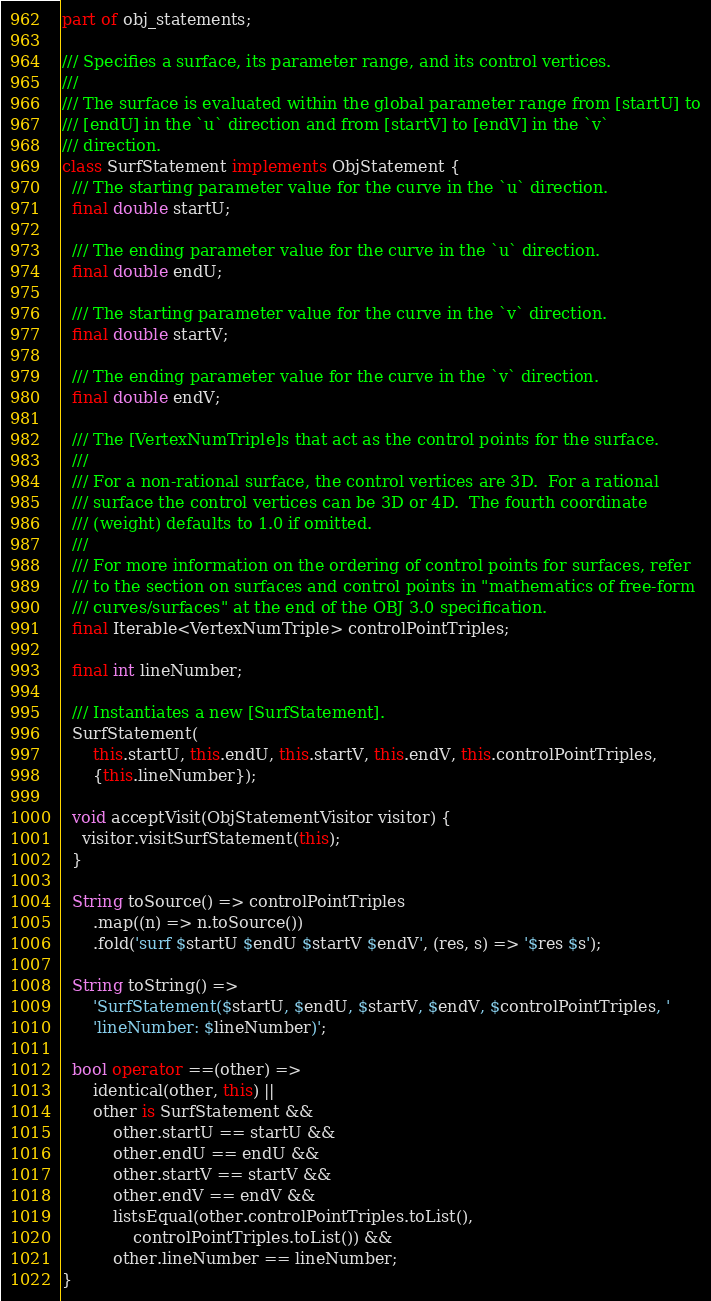<code> <loc_0><loc_0><loc_500><loc_500><_Dart_>part of obj_statements;

/// Specifies a surface, its parameter range, and its control vertices.
///
/// The surface is evaluated within the global parameter range from [startU] to
/// [endU] in the `u` direction and from [startV] to [endV] in the `v`
/// direction.
class SurfStatement implements ObjStatement {
  /// The starting parameter value for the curve in the `u` direction.
  final double startU;

  /// The ending parameter value for the curve in the `u` direction.
  final double endU;

  /// The starting parameter value for the curve in the `v` direction.
  final double startV;

  /// The ending parameter value for the curve in the `v` direction.
  final double endV;

  /// The [VertexNumTriple]s that act as the control points for the surface.
  ///
  /// For a non-rational surface, the control vertices are 3D.  For a rational
  /// surface the control vertices can be 3D or 4D.  The fourth coordinate
  /// (weight) defaults to 1.0 if omitted.
  ///
  /// For more information on the ordering of control points for surfaces, refer
  /// to the section on surfaces and control points in "mathematics of free-form
  /// curves/surfaces" at the end of the OBJ 3.0 specification.
  final Iterable<VertexNumTriple> controlPointTriples;

  final int lineNumber;

  /// Instantiates a new [SurfStatement].
  SurfStatement(
      this.startU, this.endU, this.startV, this.endV, this.controlPointTriples,
      {this.lineNumber});

  void acceptVisit(ObjStatementVisitor visitor) {
    visitor.visitSurfStatement(this);
  }

  String toSource() => controlPointTriples
      .map((n) => n.toSource())
      .fold('surf $startU $endU $startV $endV', (res, s) => '$res $s');

  String toString() =>
      'SurfStatement($startU, $endU, $startV, $endV, $controlPointTriples, '
      'lineNumber: $lineNumber)';

  bool operator ==(other) =>
      identical(other, this) ||
      other is SurfStatement &&
          other.startU == startU &&
          other.endU == endU &&
          other.startV == startV &&
          other.endV == endV &&
          listsEqual(other.controlPointTriples.toList(),
              controlPointTriples.toList()) &&
          other.lineNumber == lineNumber;
}
</code> 